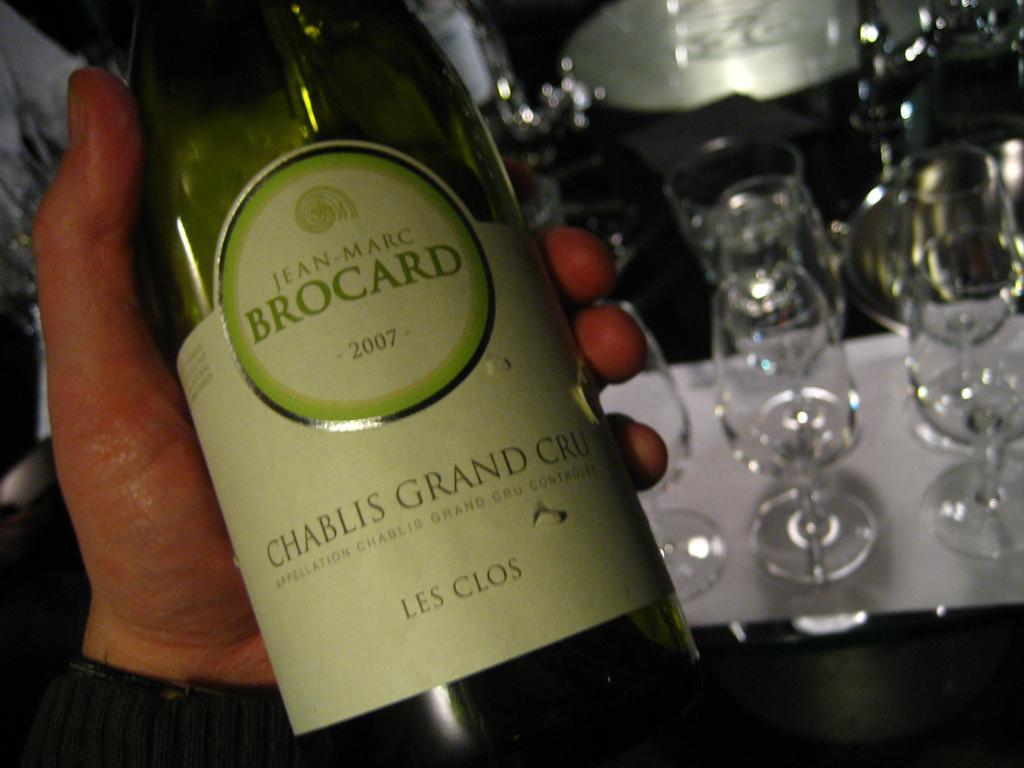Describe this image in one or two sentences. In this picture we can see a person hand is holding a bottle with sticker on it and in the background we can see glasses. 